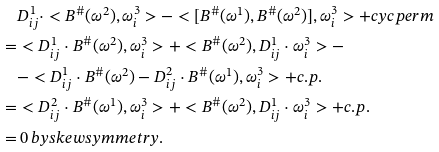<formula> <loc_0><loc_0><loc_500><loc_500>& D ^ { 1 } _ { i j } \cdot < { B ^ { \# } } ( \omega ^ { 2 } ) , \omega ^ { 3 } _ { i } > - < [ { B ^ { \# } } ( \omega ^ { 1 } ) , { B ^ { \# } } ( \omega ^ { 2 } ) ] , \omega ^ { 3 } _ { i } > + c y c p e r m \\ = & < D ^ { 1 } _ { i j } \cdot { B ^ { \# } } ( \omega ^ { 2 } ) , \omega ^ { 3 } _ { i } > + < { B ^ { \# } } ( \omega ^ { 2 } ) , D ^ { 1 } _ { i j } \cdot \omega ^ { 3 } _ { i } > - \\ & - < D ^ { 1 } _ { i j } \cdot { B ^ { \# } } ( \omega ^ { 2 } ) - D ^ { 2 } _ { i j } \cdot { B ^ { \# } } ( \omega ^ { 1 } ) , \omega ^ { 3 } _ { i } > + c . p . \\ = & < D ^ { 2 } _ { i j } \cdot { B ^ { \# } } ( \omega ^ { 1 } ) , \omega ^ { 3 } _ { i } > + < { B ^ { \# } } ( \omega ^ { 2 } ) , D ^ { 1 } _ { i j } \cdot \omega ^ { 3 } _ { i } > + c . p . \\ = & \, 0 \, b y s k e w s y m m e t r y .</formula> 